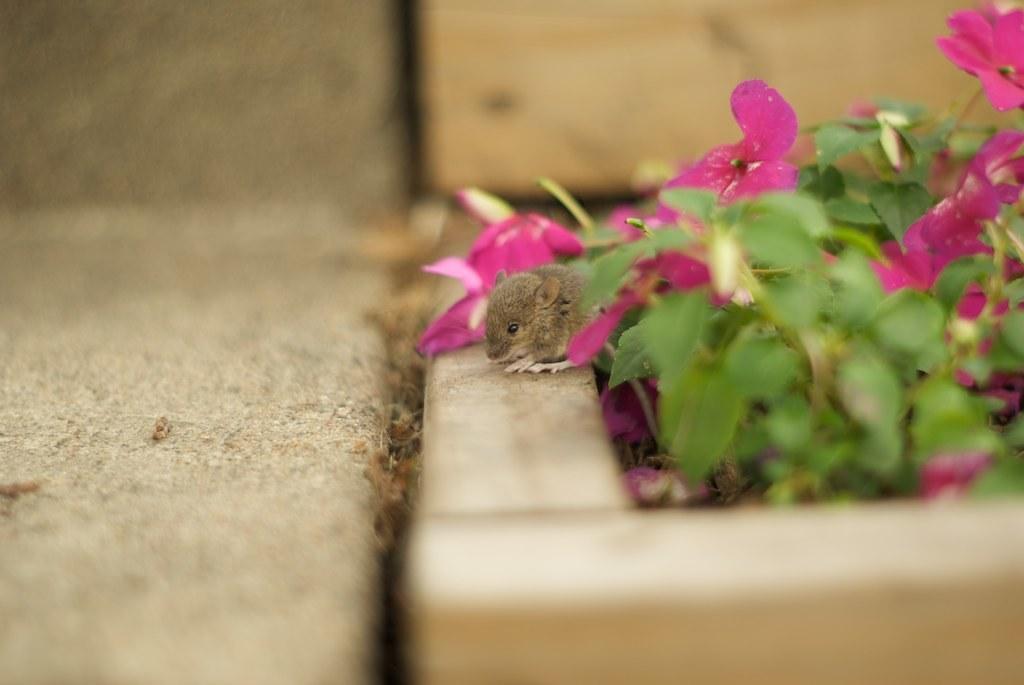How would you summarize this image in a sentence or two? In this picture we can see a rat, flowers and leaves. Behind the flowers there is the blurred background. 